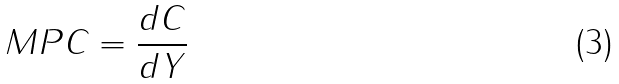<formula> <loc_0><loc_0><loc_500><loc_500>M P C = \frac { d C } { d Y }</formula> 